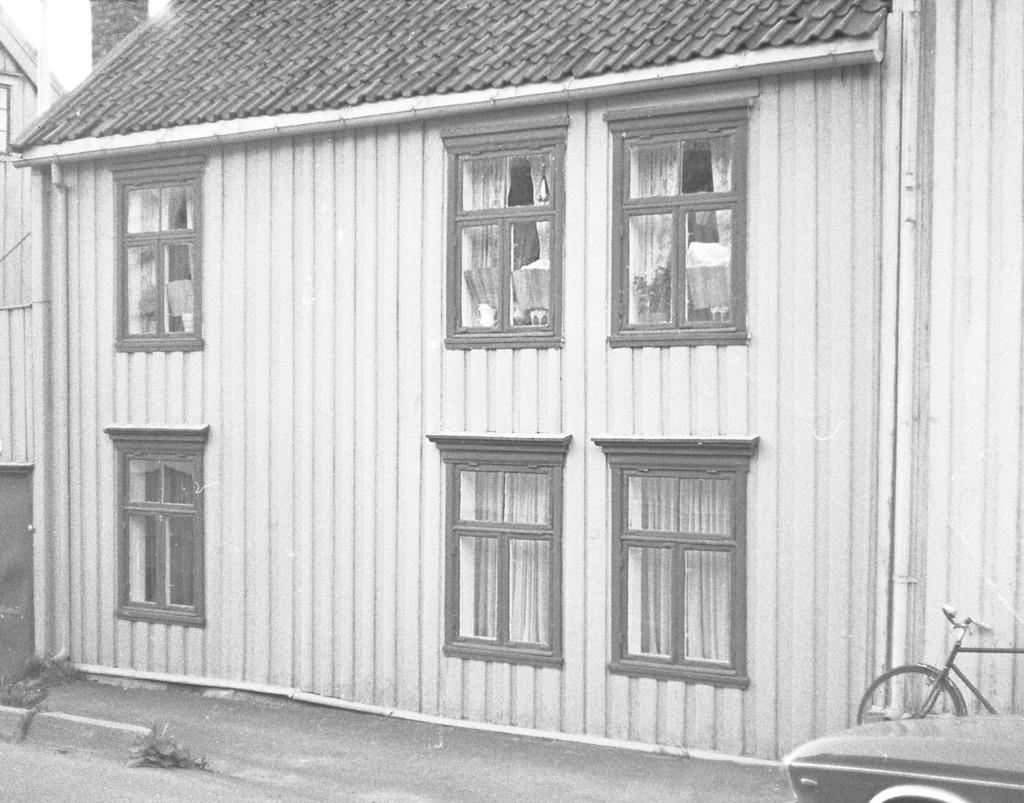What type of structure is visible in the image? There is a house in the image. What feature of the house can be seen? The house has windows. What objects are on the right side of the image? There is a bicycle and a car on the right side of the image. How many pizzas are being delivered by the ghost in the image? There is no ghost or pizza present in the image. What type of stamp is visible on the car in the image? There is no stamp visible on the car in the image. 